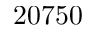<formula> <loc_0><loc_0><loc_500><loc_500>2 0 7 5 0</formula> 